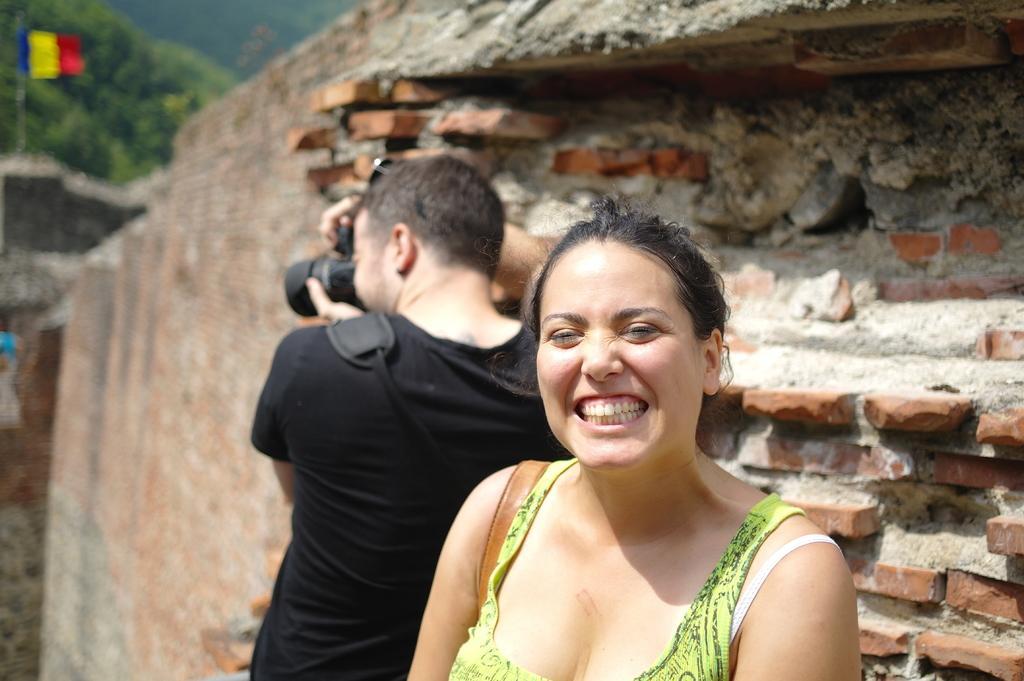Describe this image in one or two sentences. In this picture there is a woman smiling and there is a person behind her is holding a camera in his hands and there is a brick wall behind them and there are trees and a flag in the left top corner. 